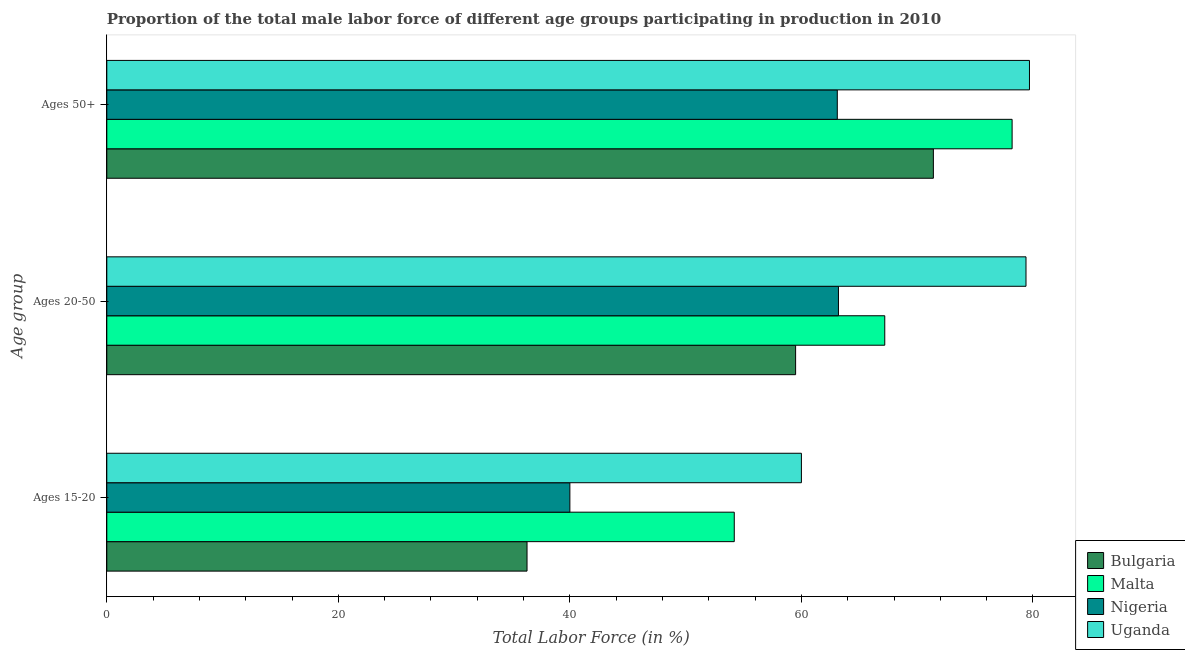How many groups of bars are there?
Provide a short and direct response. 3. Are the number of bars per tick equal to the number of legend labels?
Keep it short and to the point. Yes. What is the label of the 2nd group of bars from the top?
Give a very brief answer. Ages 20-50. What is the percentage of male labor force within the age group 20-50 in Nigeria?
Offer a terse response. 63.2. Across all countries, what is the maximum percentage of male labor force within the age group 20-50?
Provide a short and direct response. 79.4. Across all countries, what is the minimum percentage of male labor force within the age group 15-20?
Offer a very short reply. 36.3. In which country was the percentage of male labor force within the age group 20-50 maximum?
Ensure brevity in your answer.  Uganda. In which country was the percentage of male labor force above age 50 minimum?
Keep it short and to the point. Nigeria. What is the total percentage of male labor force above age 50 in the graph?
Your response must be concise. 292.4. What is the difference between the percentage of male labor force within the age group 20-50 in Malta and that in Uganda?
Make the answer very short. -12.2. What is the difference between the percentage of male labor force within the age group 20-50 in Uganda and the percentage of male labor force above age 50 in Nigeria?
Ensure brevity in your answer.  16.3. What is the average percentage of male labor force within the age group 15-20 per country?
Your answer should be compact. 47.62. What is the difference between the percentage of male labor force within the age group 20-50 and percentage of male labor force above age 50 in Malta?
Offer a terse response. -11. What is the ratio of the percentage of male labor force within the age group 20-50 in Bulgaria to that in Uganda?
Make the answer very short. 0.75. Is the percentage of male labor force within the age group 15-20 in Nigeria less than that in Uganda?
Your response must be concise. Yes. Is the difference between the percentage of male labor force within the age group 20-50 in Bulgaria and Malta greater than the difference between the percentage of male labor force within the age group 15-20 in Bulgaria and Malta?
Your response must be concise. Yes. What is the difference between the highest and the second highest percentage of male labor force within the age group 20-50?
Your answer should be very brief. 12.2. What is the difference between the highest and the lowest percentage of male labor force within the age group 20-50?
Your response must be concise. 19.9. What does the 1st bar from the top in Ages 50+ represents?
Make the answer very short. Uganda. Is it the case that in every country, the sum of the percentage of male labor force within the age group 15-20 and percentage of male labor force within the age group 20-50 is greater than the percentage of male labor force above age 50?
Provide a short and direct response. Yes. How many countries are there in the graph?
Give a very brief answer. 4. Does the graph contain any zero values?
Keep it short and to the point. No. Where does the legend appear in the graph?
Give a very brief answer. Bottom right. What is the title of the graph?
Provide a succinct answer. Proportion of the total male labor force of different age groups participating in production in 2010. Does "Kosovo" appear as one of the legend labels in the graph?
Make the answer very short. No. What is the label or title of the X-axis?
Make the answer very short. Total Labor Force (in %). What is the label or title of the Y-axis?
Ensure brevity in your answer.  Age group. What is the Total Labor Force (in %) in Bulgaria in Ages 15-20?
Your answer should be compact. 36.3. What is the Total Labor Force (in %) of Malta in Ages 15-20?
Offer a very short reply. 54.2. What is the Total Labor Force (in %) in Nigeria in Ages 15-20?
Provide a succinct answer. 40. What is the Total Labor Force (in %) of Bulgaria in Ages 20-50?
Provide a short and direct response. 59.5. What is the Total Labor Force (in %) in Malta in Ages 20-50?
Your response must be concise. 67.2. What is the Total Labor Force (in %) of Nigeria in Ages 20-50?
Your answer should be compact. 63.2. What is the Total Labor Force (in %) in Uganda in Ages 20-50?
Keep it short and to the point. 79.4. What is the Total Labor Force (in %) of Bulgaria in Ages 50+?
Offer a very short reply. 71.4. What is the Total Labor Force (in %) of Malta in Ages 50+?
Offer a very short reply. 78.2. What is the Total Labor Force (in %) in Nigeria in Ages 50+?
Offer a very short reply. 63.1. What is the Total Labor Force (in %) in Uganda in Ages 50+?
Your answer should be compact. 79.7. Across all Age group, what is the maximum Total Labor Force (in %) in Bulgaria?
Provide a succinct answer. 71.4. Across all Age group, what is the maximum Total Labor Force (in %) in Malta?
Provide a short and direct response. 78.2. Across all Age group, what is the maximum Total Labor Force (in %) in Nigeria?
Provide a succinct answer. 63.2. Across all Age group, what is the maximum Total Labor Force (in %) of Uganda?
Provide a succinct answer. 79.7. Across all Age group, what is the minimum Total Labor Force (in %) in Bulgaria?
Make the answer very short. 36.3. Across all Age group, what is the minimum Total Labor Force (in %) of Malta?
Offer a terse response. 54.2. Across all Age group, what is the minimum Total Labor Force (in %) of Uganda?
Your answer should be compact. 60. What is the total Total Labor Force (in %) in Bulgaria in the graph?
Offer a very short reply. 167.2. What is the total Total Labor Force (in %) in Malta in the graph?
Ensure brevity in your answer.  199.6. What is the total Total Labor Force (in %) of Nigeria in the graph?
Your response must be concise. 166.3. What is the total Total Labor Force (in %) in Uganda in the graph?
Your response must be concise. 219.1. What is the difference between the Total Labor Force (in %) in Bulgaria in Ages 15-20 and that in Ages 20-50?
Offer a very short reply. -23.2. What is the difference between the Total Labor Force (in %) of Nigeria in Ages 15-20 and that in Ages 20-50?
Provide a succinct answer. -23.2. What is the difference between the Total Labor Force (in %) of Uganda in Ages 15-20 and that in Ages 20-50?
Your response must be concise. -19.4. What is the difference between the Total Labor Force (in %) in Bulgaria in Ages 15-20 and that in Ages 50+?
Your response must be concise. -35.1. What is the difference between the Total Labor Force (in %) in Nigeria in Ages 15-20 and that in Ages 50+?
Ensure brevity in your answer.  -23.1. What is the difference between the Total Labor Force (in %) in Uganda in Ages 15-20 and that in Ages 50+?
Your response must be concise. -19.7. What is the difference between the Total Labor Force (in %) in Bulgaria in Ages 20-50 and that in Ages 50+?
Provide a succinct answer. -11.9. What is the difference between the Total Labor Force (in %) in Bulgaria in Ages 15-20 and the Total Labor Force (in %) in Malta in Ages 20-50?
Ensure brevity in your answer.  -30.9. What is the difference between the Total Labor Force (in %) in Bulgaria in Ages 15-20 and the Total Labor Force (in %) in Nigeria in Ages 20-50?
Give a very brief answer. -26.9. What is the difference between the Total Labor Force (in %) in Bulgaria in Ages 15-20 and the Total Labor Force (in %) in Uganda in Ages 20-50?
Provide a succinct answer. -43.1. What is the difference between the Total Labor Force (in %) in Malta in Ages 15-20 and the Total Labor Force (in %) in Nigeria in Ages 20-50?
Provide a short and direct response. -9. What is the difference between the Total Labor Force (in %) in Malta in Ages 15-20 and the Total Labor Force (in %) in Uganda in Ages 20-50?
Make the answer very short. -25.2. What is the difference between the Total Labor Force (in %) in Nigeria in Ages 15-20 and the Total Labor Force (in %) in Uganda in Ages 20-50?
Make the answer very short. -39.4. What is the difference between the Total Labor Force (in %) of Bulgaria in Ages 15-20 and the Total Labor Force (in %) of Malta in Ages 50+?
Offer a terse response. -41.9. What is the difference between the Total Labor Force (in %) in Bulgaria in Ages 15-20 and the Total Labor Force (in %) in Nigeria in Ages 50+?
Give a very brief answer. -26.8. What is the difference between the Total Labor Force (in %) in Bulgaria in Ages 15-20 and the Total Labor Force (in %) in Uganda in Ages 50+?
Your answer should be very brief. -43.4. What is the difference between the Total Labor Force (in %) in Malta in Ages 15-20 and the Total Labor Force (in %) in Nigeria in Ages 50+?
Make the answer very short. -8.9. What is the difference between the Total Labor Force (in %) of Malta in Ages 15-20 and the Total Labor Force (in %) of Uganda in Ages 50+?
Make the answer very short. -25.5. What is the difference between the Total Labor Force (in %) in Nigeria in Ages 15-20 and the Total Labor Force (in %) in Uganda in Ages 50+?
Ensure brevity in your answer.  -39.7. What is the difference between the Total Labor Force (in %) of Bulgaria in Ages 20-50 and the Total Labor Force (in %) of Malta in Ages 50+?
Give a very brief answer. -18.7. What is the difference between the Total Labor Force (in %) in Bulgaria in Ages 20-50 and the Total Labor Force (in %) in Uganda in Ages 50+?
Give a very brief answer. -20.2. What is the difference between the Total Labor Force (in %) in Nigeria in Ages 20-50 and the Total Labor Force (in %) in Uganda in Ages 50+?
Provide a short and direct response. -16.5. What is the average Total Labor Force (in %) in Bulgaria per Age group?
Your response must be concise. 55.73. What is the average Total Labor Force (in %) of Malta per Age group?
Your response must be concise. 66.53. What is the average Total Labor Force (in %) of Nigeria per Age group?
Offer a terse response. 55.43. What is the average Total Labor Force (in %) of Uganda per Age group?
Provide a succinct answer. 73.03. What is the difference between the Total Labor Force (in %) of Bulgaria and Total Labor Force (in %) of Malta in Ages 15-20?
Make the answer very short. -17.9. What is the difference between the Total Labor Force (in %) in Bulgaria and Total Labor Force (in %) in Uganda in Ages 15-20?
Provide a succinct answer. -23.7. What is the difference between the Total Labor Force (in %) in Malta and Total Labor Force (in %) in Uganda in Ages 15-20?
Provide a succinct answer. -5.8. What is the difference between the Total Labor Force (in %) in Bulgaria and Total Labor Force (in %) in Malta in Ages 20-50?
Provide a short and direct response. -7.7. What is the difference between the Total Labor Force (in %) in Bulgaria and Total Labor Force (in %) in Uganda in Ages 20-50?
Your answer should be compact. -19.9. What is the difference between the Total Labor Force (in %) of Malta and Total Labor Force (in %) of Uganda in Ages 20-50?
Offer a very short reply. -12.2. What is the difference between the Total Labor Force (in %) of Nigeria and Total Labor Force (in %) of Uganda in Ages 20-50?
Your answer should be compact. -16.2. What is the difference between the Total Labor Force (in %) of Bulgaria and Total Labor Force (in %) of Malta in Ages 50+?
Provide a short and direct response. -6.8. What is the difference between the Total Labor Force (in %) of Bulgaria and Total Labor Force (in %) of Uganda in Ages 50+?
Your answer should be very brief. -8.3. What is the difference between the Total Labor Force (in %) of Malta and Total Labor Force (in %) of Nigeria in Ages 50+?
Keep it short and to the point. 15.1. What is the difference between the Total Labor Force (in %) of Nigeria and Total Labor Force (in %) of Uganda in Ages 50+?
Provide a short and direct response. -16.6. What is the ratio of the Total Labor Force (in %) of Bulgaria in Ages 15-20 to that in Ages 20-50?
Ensure brevity in your answer.  0.61. What is the ratio of the Total Labor Force (in %) in Malta in Ages 15-20 to that in Ages 20-50?
Your response must be concise. 0.81. What is the ratio of the Total Labor Force (in %) of Nigeria in Ages 15-20 to that in Ages 20-50?
Your response must be concise. 0.63. What is the ratio of the Total Labor Force (in %) of Uganda in Ages 15-20 to that in Ages 20-50?
Give a very brief answer. 0.76. What is the ratio of the Total Labor Force (in %) of Bulgaria in Ages 15-20 to that in Ages 50+?
Ensure brevity in your answer.  0.51. What is the ratio of the Total Labor Force (in %) of Malta in Ages 15-20 to that in Ages 50+?
Make the answer very short. 0.69. What is the ratio of the Total Labor Force (in %) in Nigeria in Ages 15-20 to that in Ages 50+?
Your answer should be compact. 0.63. What is the ratio of the Total Labor Force (in %) in Uganda in Ages 15-20 to that in Ages 50+?
Offer a very short reply. 0.75. What is the ratio of the Total Labor Force (in %) in Bulgaria in Ages 20-50 to that in Ages 50+?
Provide a succinct answer. 0.83. What is the ratio of the Total Labor Force (in %) of Malta in Ages 20-50 to that in Ages 50+?
Ensure brevity in your answer.  0.86. What is the ratio of the Total Labor Force (in %) of Uganda in Ages 20-50 to that in Ages 50+?
Offer a terse response. 1. What is the difference between the highest and the second highest Total Labor Force (in %) of Bulgaria?
Ensure brevity in your answer.  11.9. What is the difference between the highest and the second highest Total Labor Force (in %) in Nigeria?
Provide a short and direct response. 0.1. What is the difference between the highest and the second highest Total Labor Force (in %) in Uganda?
Give a very brief answer. 0.3. What is the difference between the highest and the lowest Total Labor Force (in %) in Bulgaria?
Offer a terse response. 35.1. What is the difference between the highest and the lowest Total Labor Force (in %) of Nigeria?
Ensure brevity in your answer.  23.2. What is the difference between the highest and the lowest Total Labor Force (in %) of Uganda?
Your response must be concise. 19.7. 